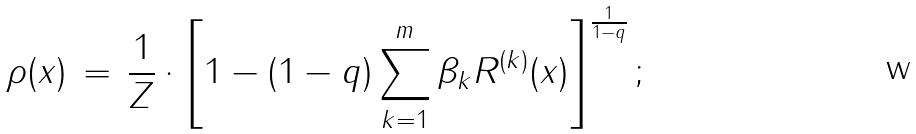<formula> <loc_0><loc_0><loc_500><loc_500>\rho ( x ) \, = \, \frac { 1 } { Z } \cdot \left [ 1 - ( 1 - q ) \sum ^ { m } _ { k = 1 } \beta _ { k } R ^ { ( k ) } ( x ) \right ] ^ { \frac { 1 } { 1 - q } } ;</formula> 